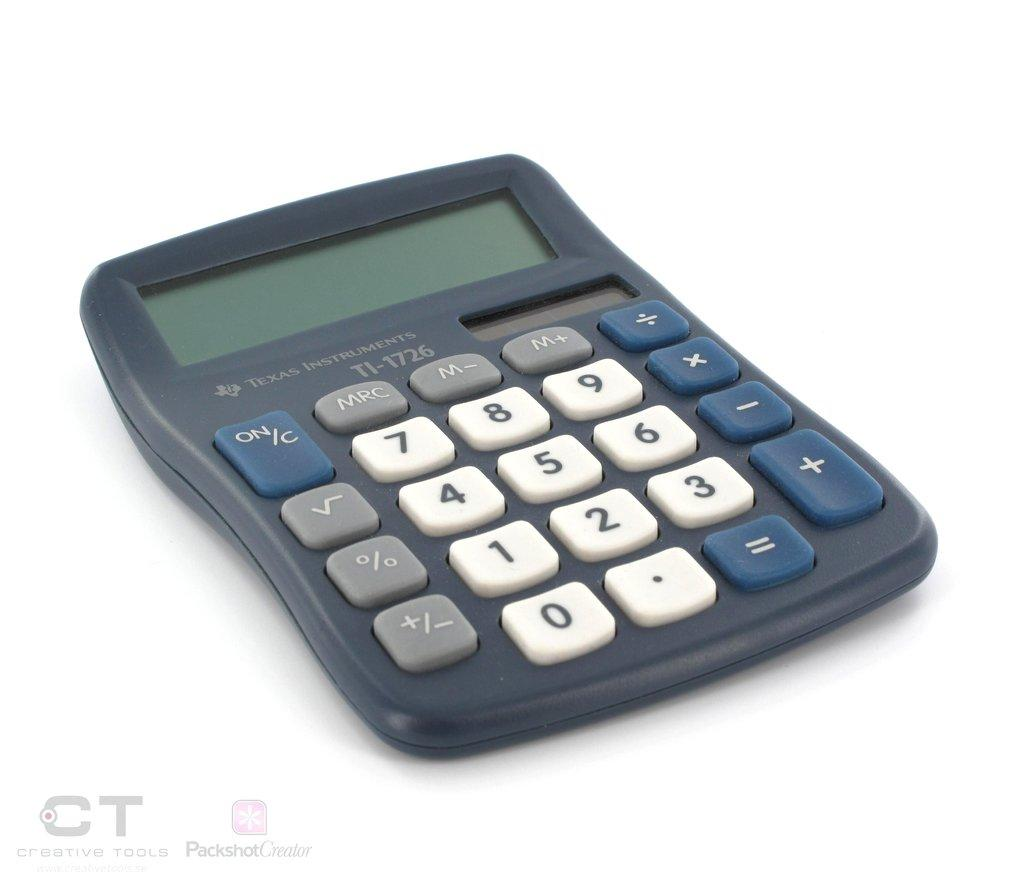What object can be seen in the image? There is a calculator in the image. What is the primary function of the object in the image? The primary function of the calculator is to perform mathematical calculations. Can you describe the appearance of the calculator in the image? The calculator appears to be a standard, handheld calculator with buttons and a display screen. What type of sail can be seen on the property in the image? There is no sail or property present in the image; it only features a calculator. 